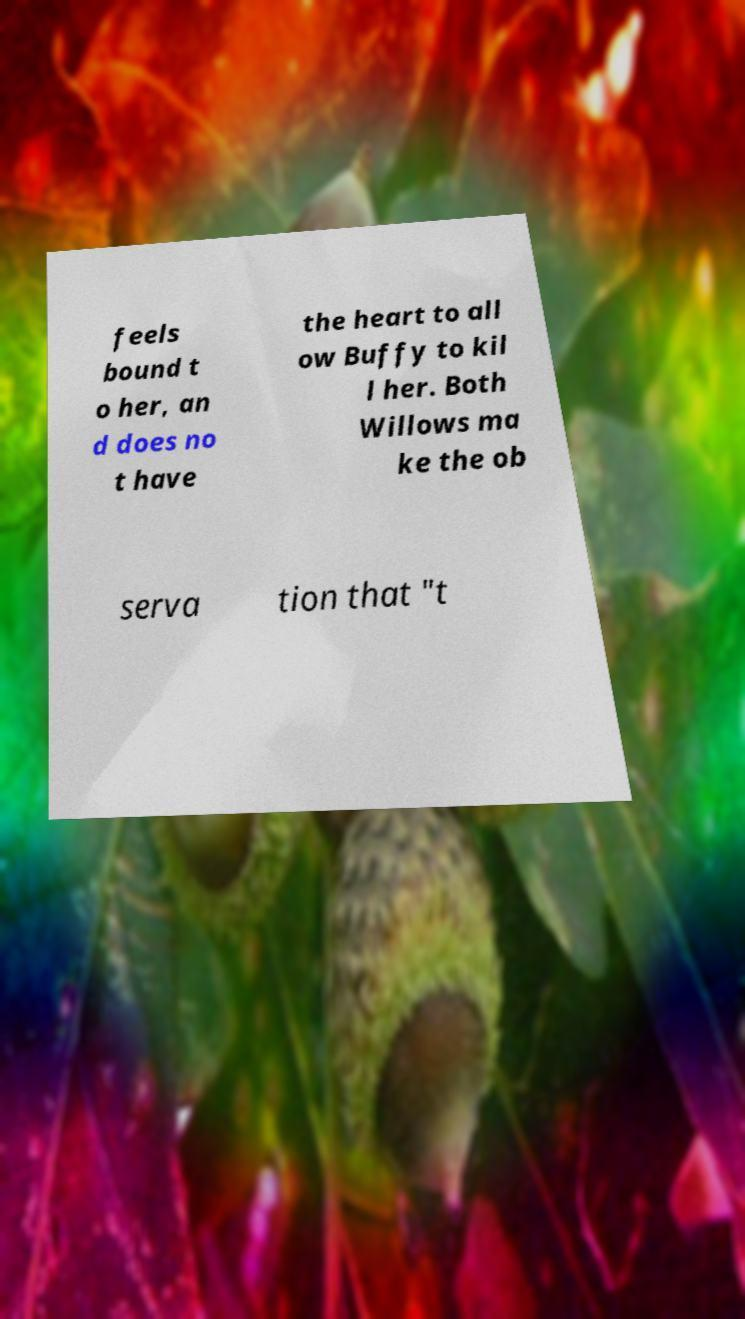Can you read and provide the text displayed in the image?This photo seems to have some interesting text. Can you extract and type it out for me? feels bound t o her, an d does no t have the heart to all ow Buffy to kil l her. Both Willows ma ke the ob serva tion that "t 